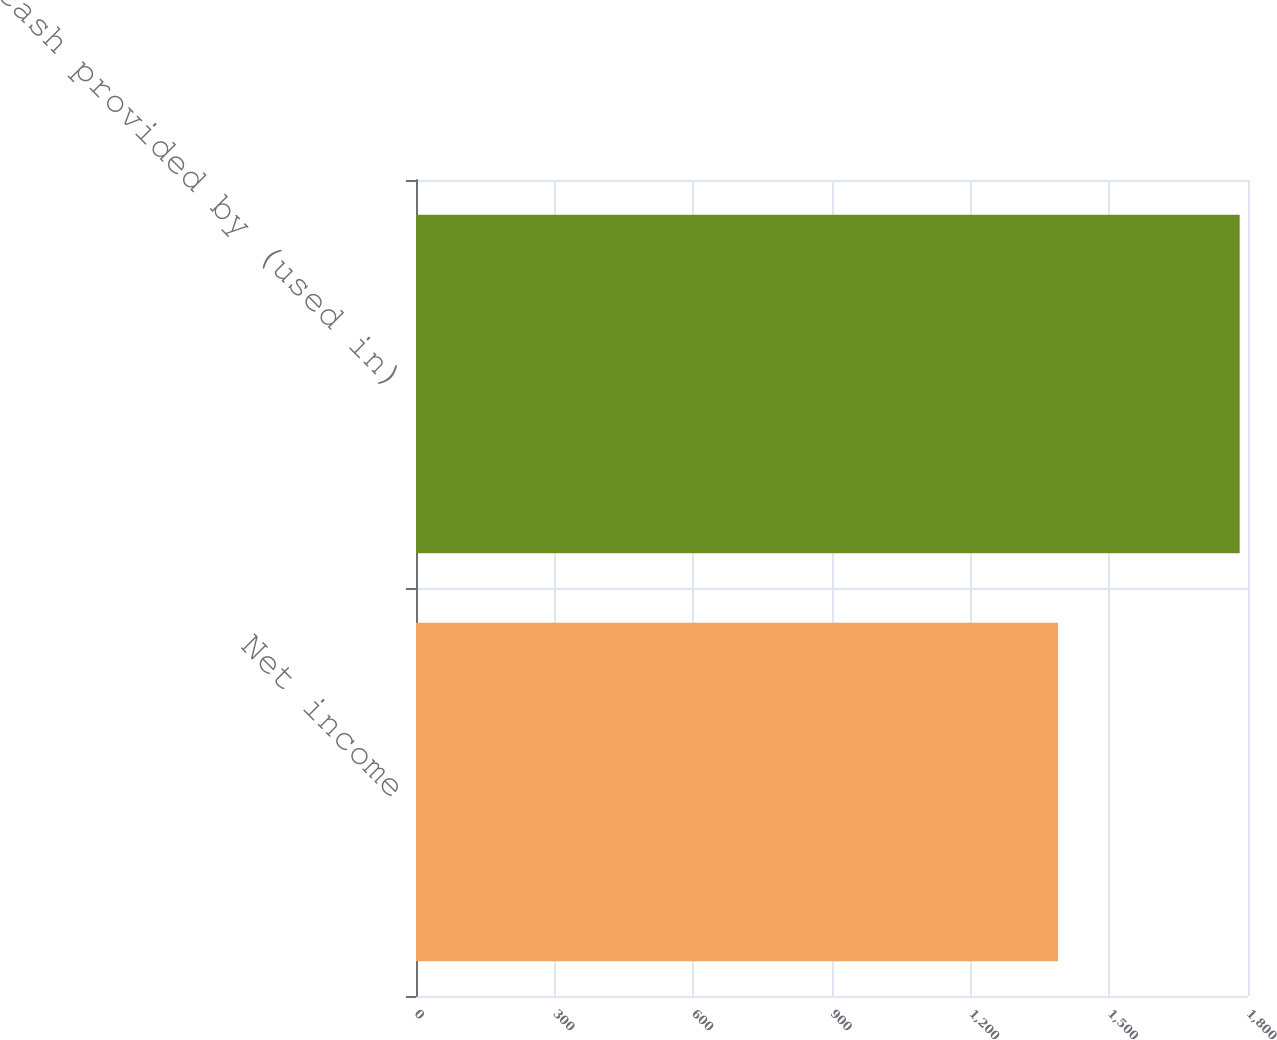Convert chart to OTSL. <chart><loc_0><loc_0><loc_500><loc_500><bar_chart><fcel>Net income<fcel>Net cash provided by (used in)<nl><fcel>1389<fcel>1782<nl></chart> 